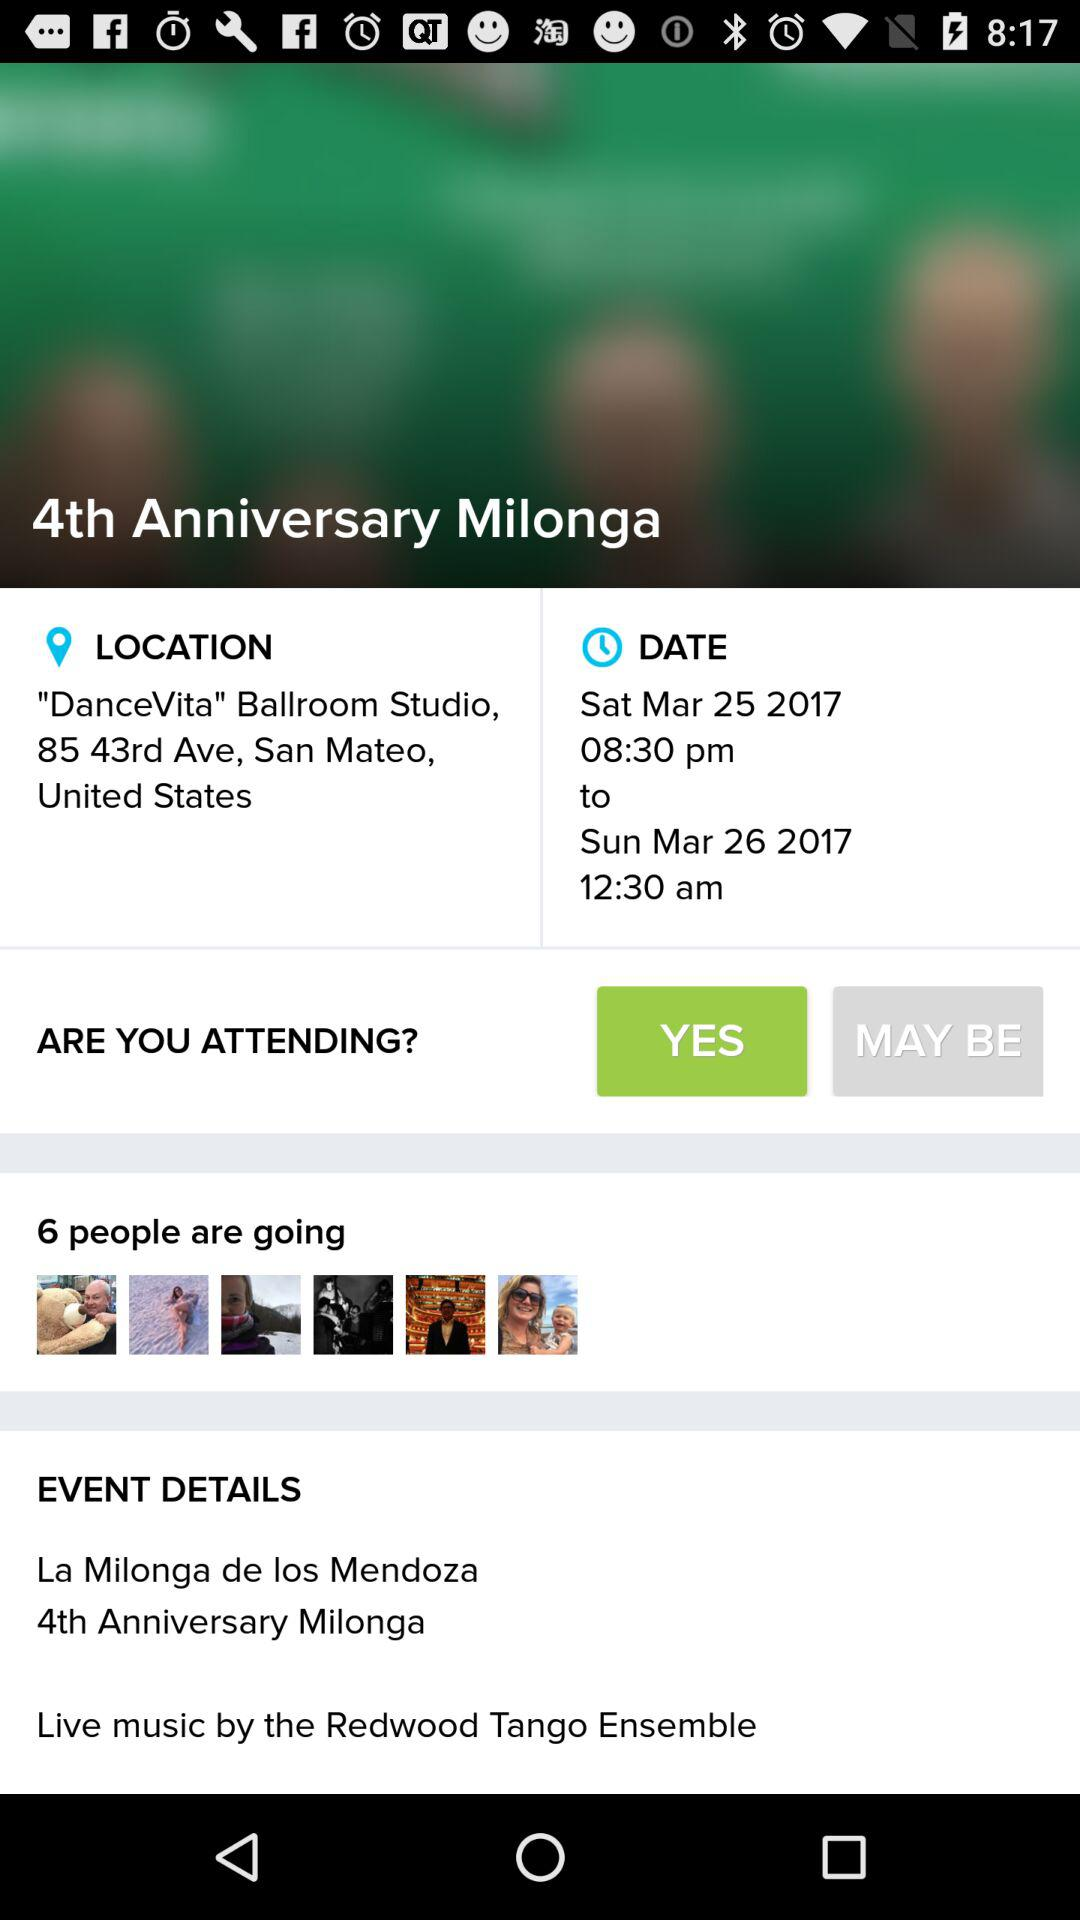What is the day on April 2? The day is Sunday. 